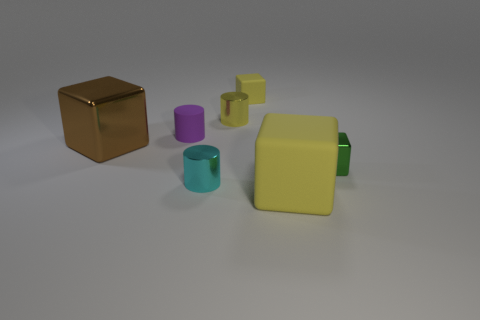There is a metal cylinder that is the same color as the small matte cube; what size is it?
Provide a short and direct response. Small. How many large shiny things are the same color as the tiny shiny cube?
Offer a very short reply. 0. How many things are metallic cylinders that are in front of the yellow cylinder or small cyan matte balls?
Offer a terse response. 1. What size is the rubber cube behind the yellow cylinder?
Ensure brevity in your answer.  Small. Are there fewer brown metal blocks than tiny blocks?
Make the answer very short. Yes. Is the material of the large cube right of the large brown thing the same as the small object behind the small yellow cylinder?
Offer a very short reply. Yes. There is a big object on the right side of the block on the left side of the tiny metal object to the left of the tiny yellow shiny object; what shape is it?
Keep it short and to the point. Cube. What number of cyan things are made of the same material as the big brown object?
Make the answer very short. 1. There is a yellow matte object right of the tiny yellow rubber object; how many cyan metallic cylinders are to the right of it?
Your answer should be compact. 0. Is the color of the small metal cylinder behind the tiny metal block the same as the matte cube that is in front of the brown object?
Provide a short and direct response. Yes. 